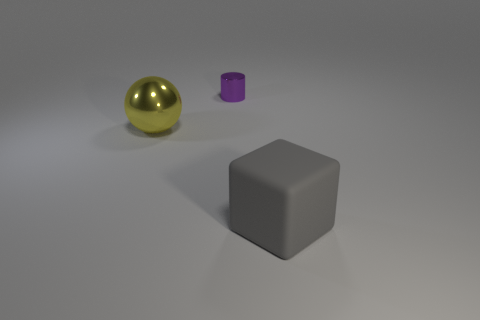What number of blue things are small blocks or big rubber blocks?
Your answer should be compact. 0. There is a object that is both on the left side of the gray rubber cube and in front of the purple cylinder; what is its size?
Offer a terse response. Large. Is the number of matte blocks that are to the left of the cylinder greater than the number of metal things?
Make the answer very short. No. What number of blocks are gray objects or cyan metallic objects?
Provide a succinct answer. 1. What is the shape of the object that is both in front of the small purple object and on the right side of the shiny sphere?
Offer a very short reply. Cube. Is the number of large cubes behind the metallic cylinder the same as the number of large gray matte things left of the rubber block?
Make the answer very short. Yes. What number of things are big brown shiny cylinders or small shiny things?
Provide a succinct answer. 1. What is the color of the sphere that is the same size as the gray matte thing?
Offer a very short reply. Yellow. How many things are either objects that are in front of the big metal sphere or things that are in front of the large metal thing?
Give a very brief answer. 1. Are there the same number of big gray matte blocks that are to the left of the large matte block and small gray rubber blocks?
Provide a succinct answer. Yes. 